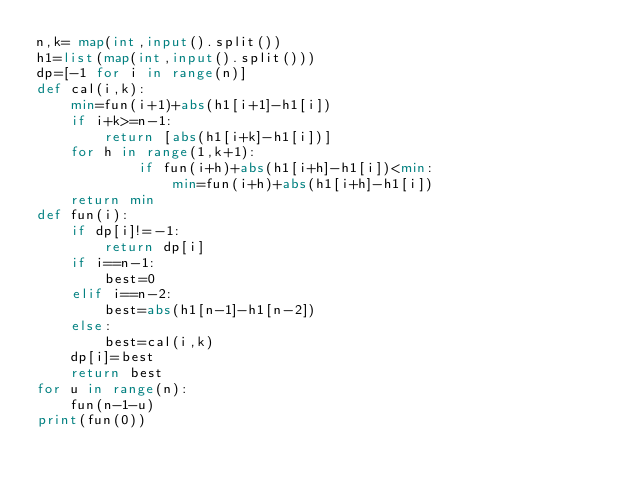<code> <loc_0><loc_0><loc_500><loc_500><_Python_>n,k= map(int,input().split())
h1=list(map(int,input().split()))
dp=[-1 for i in range(n)]
def cal(i,k):
    min=fun(i+1)+abs(h1[i+1]-h1[i])
    if i+k>=n-1:
        return [abs(h1[i+k]-h1[i])]
    for h in range(1,k+1):
            if fun(i+h)+abs(h1[i+h]-h1[i])<min:
                min=fun(i+h)+abs(h1[i+h]-h1[i])
    return min        
def fun(i):
    if dp[i]!=-1:
        return dp[i]
    if i==n-1:
        best=0
    elif i==n-2:
        best=abs(h1[n-1]-h1[n-2])
    else:
        best=cal(i,k)
    dp[i]=best
    return best
for u in range(n):
    fun(n-1-u)
print(fun(0))</code> 